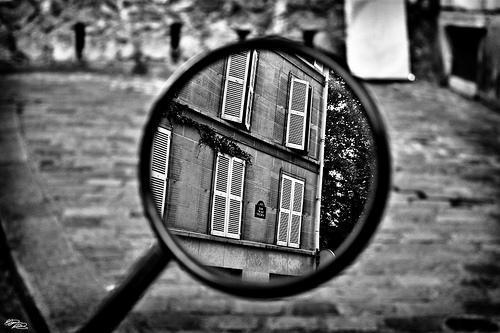How many windows are there?
Give a very brief answer. 5. 